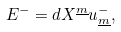Convert formula to latex. <formula><loc_0><loc_0><loc_500><loc_500>E ^ { - } = d X ^ { \underline { m } } u _ { \underline { m } } ^ { - } ,</formula> 